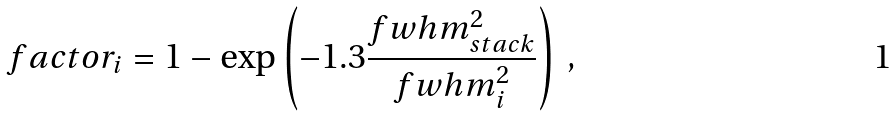Convert formula to latex. <formula><loc_0><loc_0><loc_500><loc_500>f a c t o r _ { i } = 1 - \exp \left ( - 1 . 3 \frac { f w h m _ { s t a c k } ^ { 2 } } { f w h m _ { i } ^ { 2 } } \right ) \, ,</formula> 